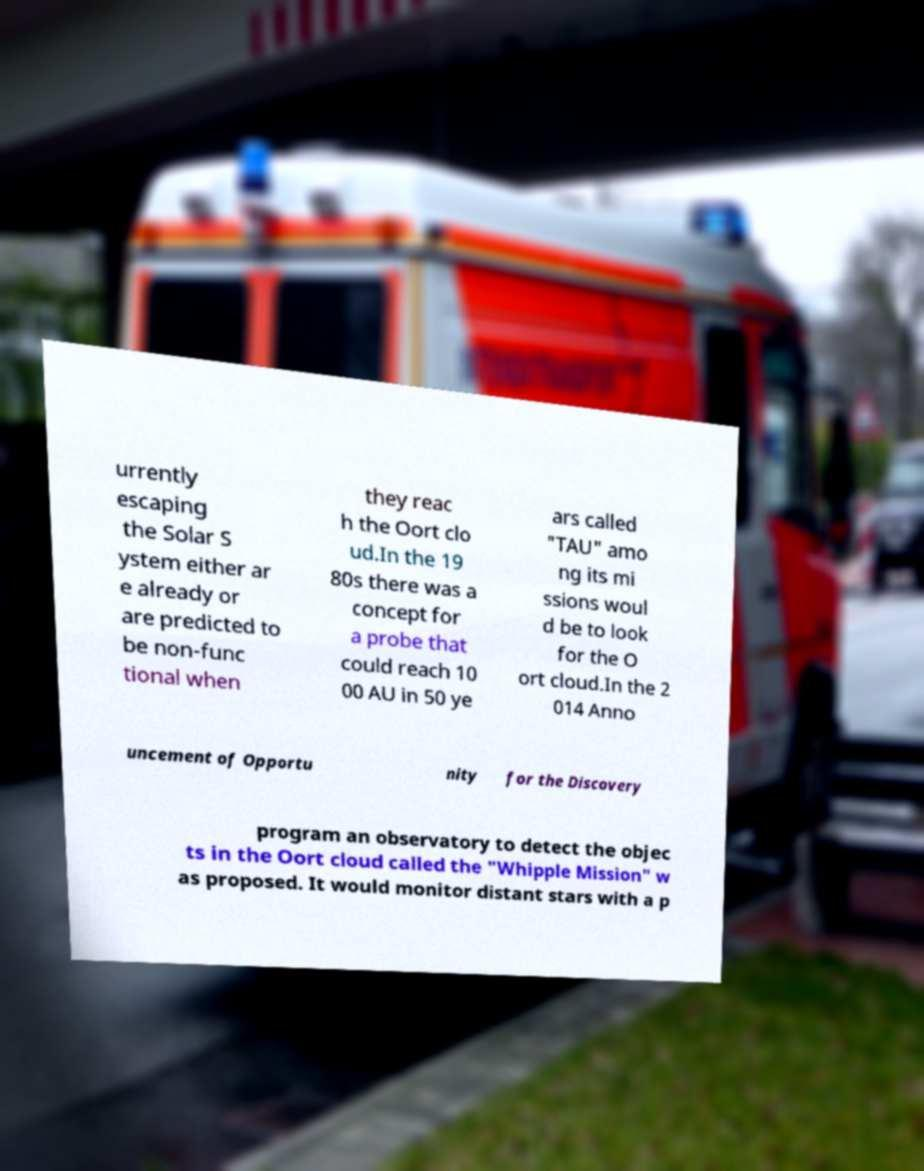There's text embedded in this image that I need extracted. Can you transcribe it verbatim? urrently escaping the Solar S ystem either ar e already or are predicted to be non-func tional when they reac h the Oort clo ud.In the 19 80s there was a concept for a probe that could reach 10 00 AU in 50 ye ars called "TAU" amo ng its mi ssions woul d be to look for the O ort cloud.In the 2 014 Anno uncement of Opportu nity for the Discovery program an observatory to detect the objec ts in the Oort cloud called the "Whipple Mission" w as proposed. It would monitor distant stars with a p 